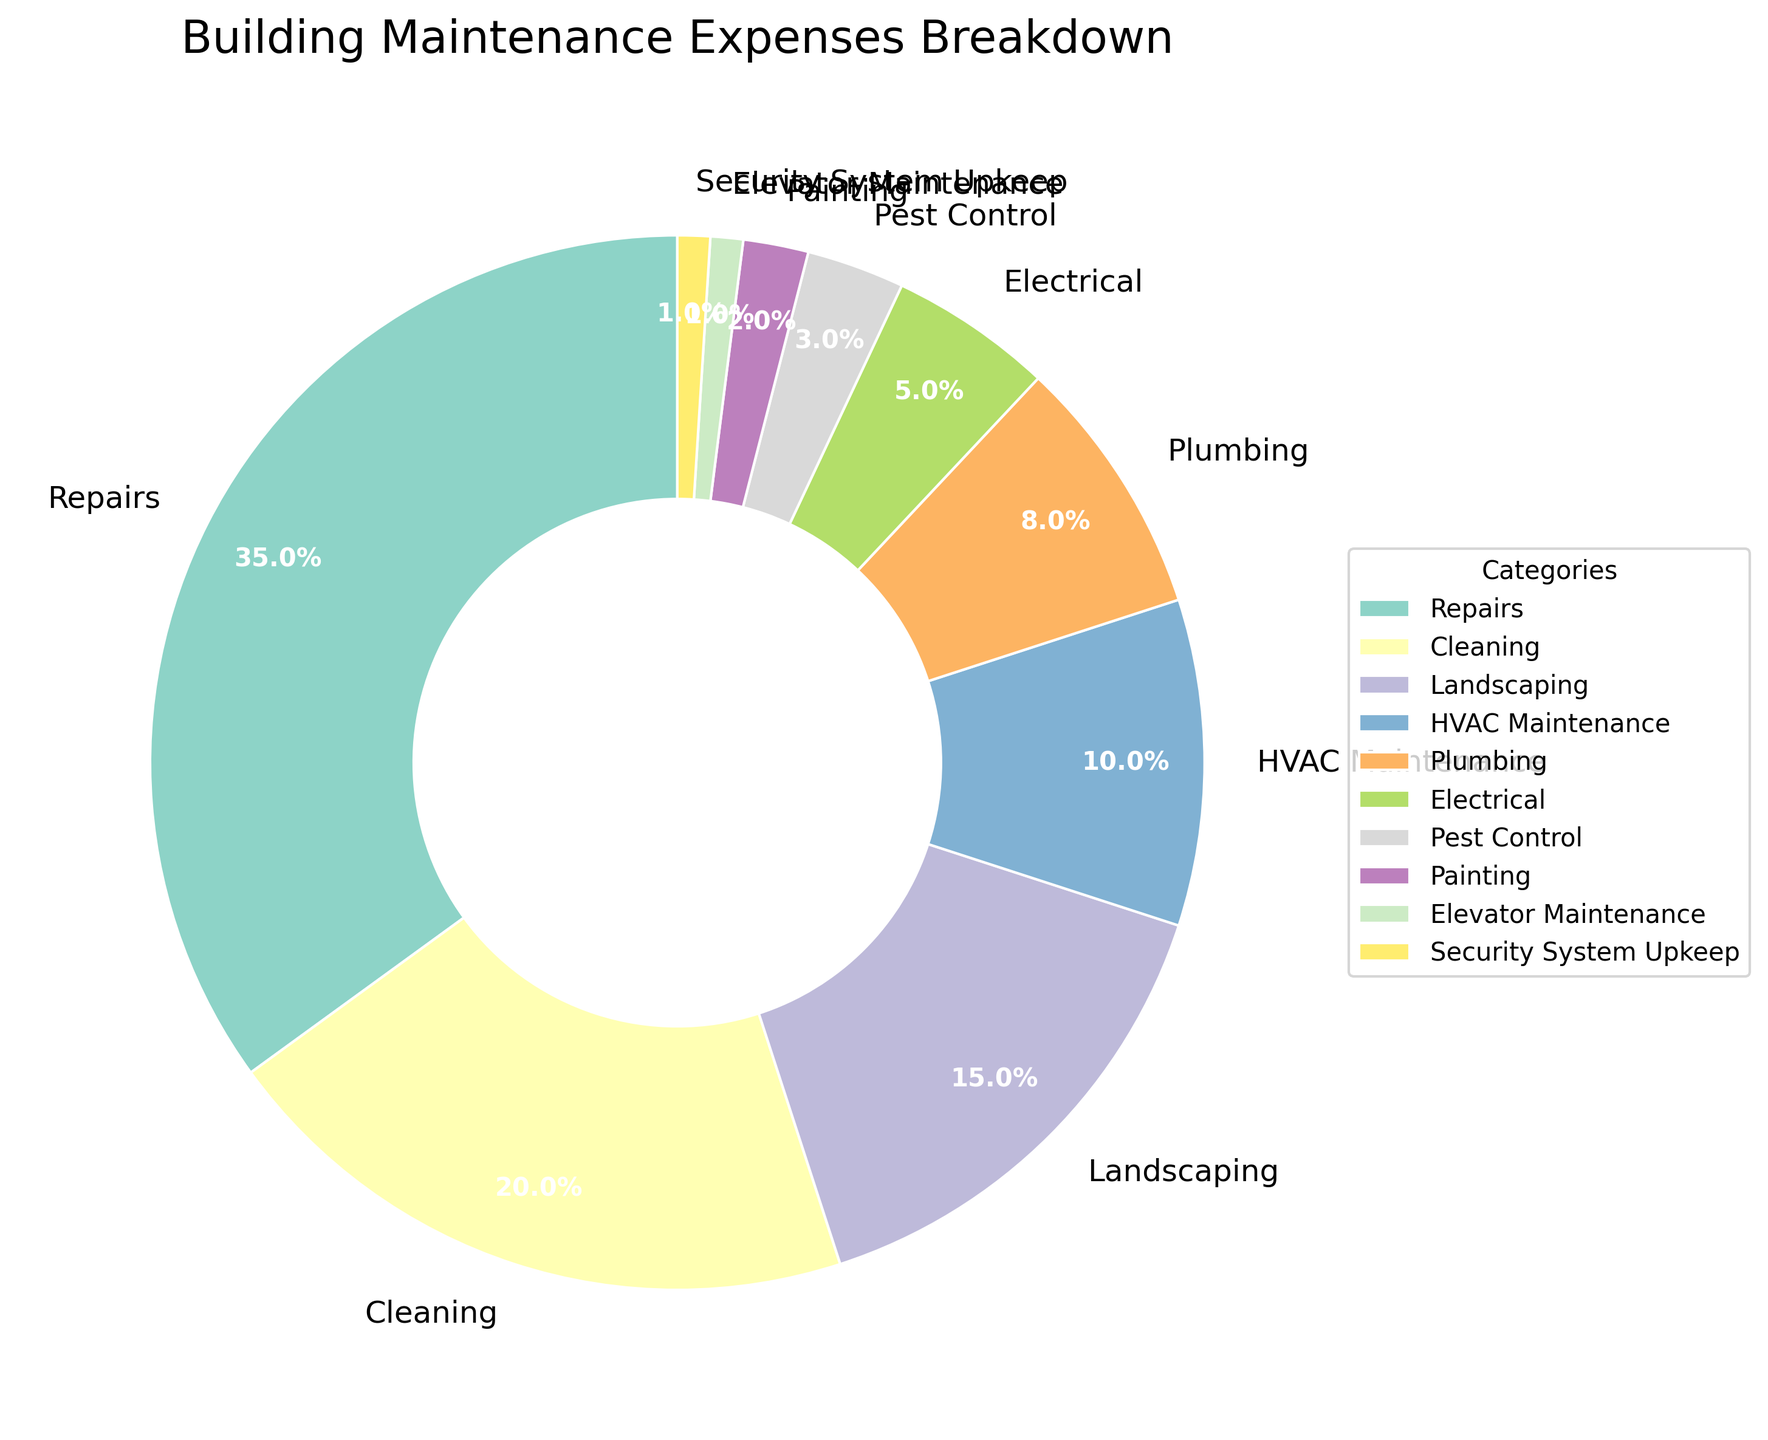Which category has the highest percentage of expenses? Look at the category with the largest pie wedge. The "Repairs" segment is the largest.
Answer: Repairs What is the combined percentage of expenses for Plumbing and Electrical? Add the percentages for the Plumbing and Electrical categories: 8% + 5% = 13%.
Answer: 13% Which category has a smaller percentage, Pest Control or Painting? Compare the percentages of Pest Control and Painting: Pest Control is 3%, and Painting is 2%. Painting has a smaller percentage.
Answer: Painting How much larger is the percentage of Repairs compared to HVAC Maintenance? Subtract the percentage of HVAC Maintenance from Repairs: 35% - 10% = 25%.
Answer: 25% What is the combined percentage of the three smallest categories? Add the percentages of the smallest categories: Elevator Maintenance (1%), Security System Upkeep (1%), and Painting (2%): 1% + 1% + 2% = 4%.
Answer: 4% What percentage is allocated to Cleaning, and how does it compare to Landscaping? Cleaning has 20%, while Landscaping has 15%. Cleaning has 5% more than Landscaping.
Answer: Cleaning has 5% more Which categories make up less than 5% of the expenses each? Look for categories with percentages less than 5%. These are Electrical (5%), Pest Control (3%), Painting (2%), Elevator Maintenance (1%), and Security System Upkeep (1%).
Answer: Electrical, Pest Control, Painting, Elevator Maintenance, Security System Upkeep What is the total percentage of expenses allocated to Repairs, Cleaning, and Landscaping combined? Add the percentages of Repairs, Cleaning, and Landscaping: 35% + 20% + 15% = 70%.
Answer: 70% Is the percentage of Cleaning higher than the combined percentage of Elevator Maintenance, Security System Upkeep, and Plumbing? Cleaning is 20%. The combined percentage of Elevator Maintenance (1%), Security System Upkeep (1%), and Plumbing (8%) is 1% + 1% + 8% = 10%. Hence, Cleaning is higher.
Answer: Yes Which category has the smallest percentage, and what is it? Find the category with the smallest wedge: both Elevator Maintenance and Security System Upkeep have the smallest percentage, which is 1%.
Answer: Elevator Maintenance and Security System Upkeep, 1% 